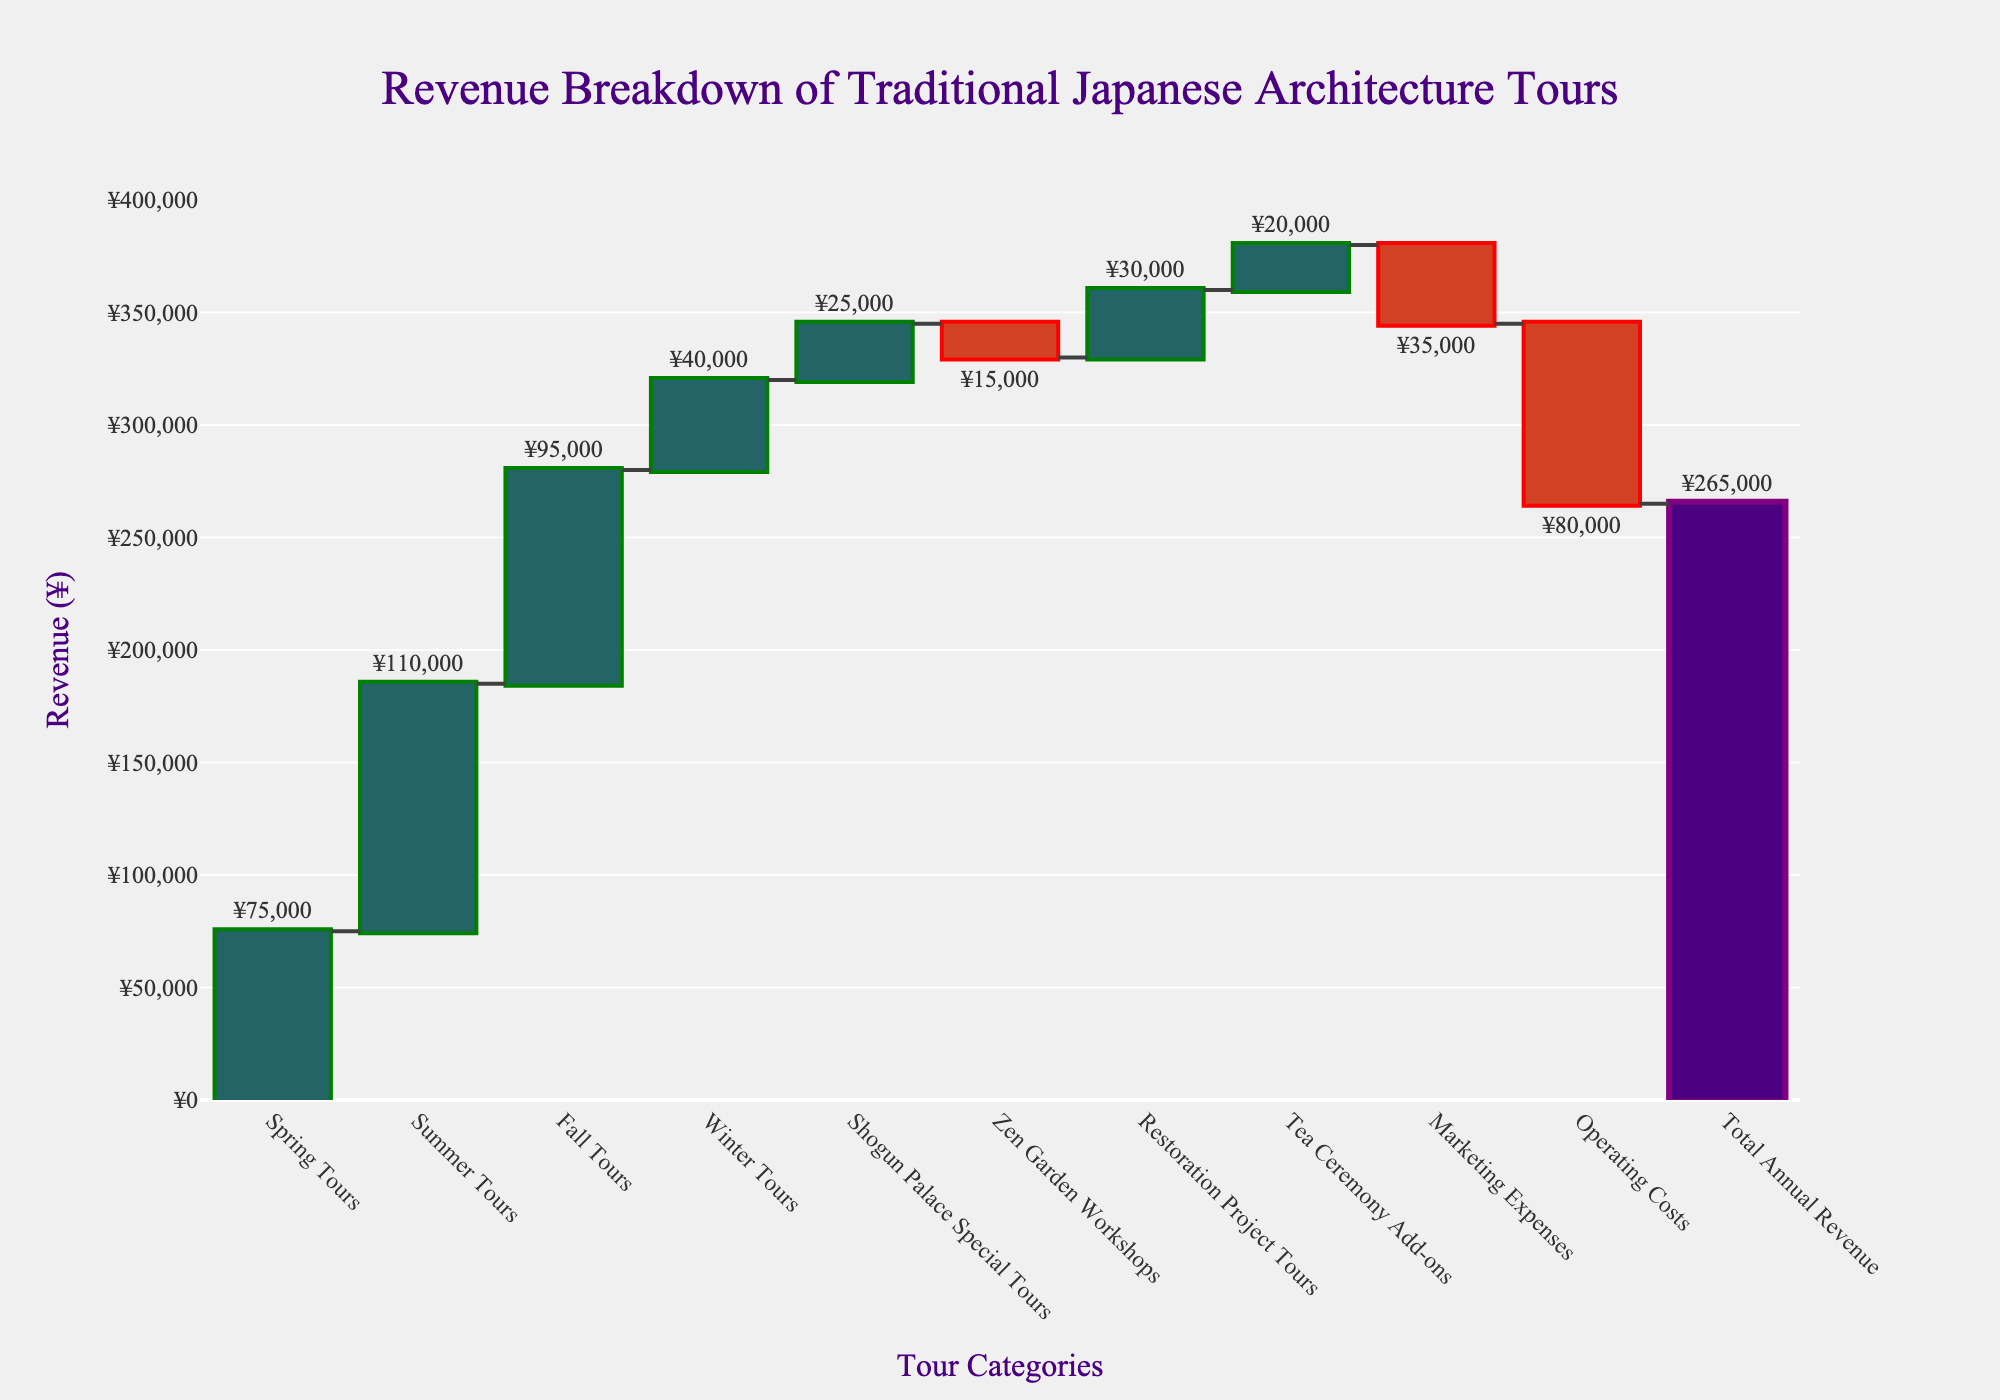What is the title of the chart? The title of the chart is located at the top and centre of the figure. It is often larger in font size and distinct in color to stand out.
Answer: Revenue Breakdown of Traditional Japanese Architecture Tours How many categories of tours are contributing positively to the revenue? A category contributes positively if its bar's color indicates an increase. By looking at the colors representing increases, count these tour categories.
Answer: 7 Which tour category had the highest positive revenue contribution? Identify the tallest bar among the bars representing positive revenue contributions by looking at their lengths and corresponding categories.
Answer: Summer Tours What is the revenue difference between Spring Tours and Winter Tours? Locate the bars for Spring Tours and Winter Tours, note their values, and subtract the Winter Tours value from the Spring Tours value.
Answer: ¥35,000 Between Summer Tours and Fall Tours, which had a greater contribution to revenue? Compare the heights or values of the bars for Summer Tours and Fall Tours to determine which is larger.
Answer: Summer Tours What are the negative contributions to the revenue and their respective values? Identify bars indicating a decrease in revenue by their distinctive color for decreases, and list their values.
Answer: Zen Garden Workshops: ¥15,000, Marketing Expenses: ¥35,000, Operating Costs: ¥80,000 What's the combined revenue value of Spring Tours, Summer Tours, and Fall Tours? Sum the values of the bars for Spring Tours, Summer Tours, and Fall Tours by adding their respective amounts.
Answer: ¥280,000 How does the total annual revenue compare to the sum of all positive contributions? Find the total annual revenue, which is the concluding bar, and compare it to the sum of all bars representing positive contributions. This may involve adding all positive values and comparing them to the total annual revenue.
Answer: Equal Why might the Winter Tours have the lowest revenue contribution compared to other seasonal tours? Analyze the potential reasons like lower tourist inflow during winter, fewer tour offerings, seasonal preferences, etc., based on trends and known facts about tourism.
Answer: Fewer tourists in winter What is the net effect of Marketing Expenses and Operating Costs on the total revenue? Add the values of Marketing Expenses and Operating Costs, noting both are negative, to find their combined effect on the total revenue.
Answer: -¥115,000 